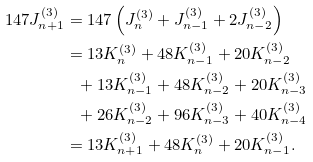Convert formula to latex. <formula><loc_0><loc_0><loc_500><loc_500>1 4 7 J _ { n + 1 } ^ { ( 3 ) } & = 1 4 7 \left ( J _ { n } ^ { ( 3 ) } + J _ { n - 1 } ^ { ( 3 ) } + 2 J _ { n - 2 } ^ { ( 3 ) } \right ) \\ & = 1 3 K _ { n } ^ { ( 3 ) } + 4 8 K _ { n - 1 } ^ { ( 3 ) } + 2 0 K _ { n - 2 } ^ { ( 3 ) } \\ & \ \ + 1 3 K _ { n - 1 } ^ { ( 3 ) } + 4 8 K _ { n - 2 } ^ { ( 3 ) } + 2 0 K _ { n - 3 } ^ { ( 3 ) } \\ & \ \ + 2 6 K _ { n - 2 } ^ { ( 3 ) } + 9 6 K _ { n - 3 } ^ { ( 3 ) } + 4 0 K _ { n - 4 } ^ { ( 3 ) } \\ & = 1 3 K _ { n + 1 } ^ { ( 3 ) } + 4 8 K _ { n } ^ { ( 3 ) } + 2 0 K _ { n - 1 } ^ { ( 3 ) } .</formula> 